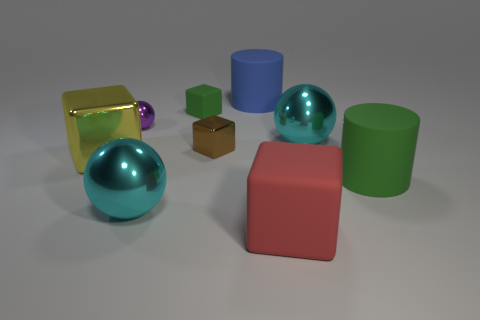Add 1 small balls. How many objects exist? 10 Subtract all cylinders. How many objects are left? 7 Add 1 tiny purple shiny balls. How many tiny purple shiny balls are left? 2 Add 5 big yellow things. How many big yellow things exist? 6 Subtract 0 red spheres. How many objects are left? 9 Subtract all cyan objects. Subtract all small rubber cubes. How many objects are left? 6 